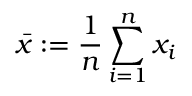Convert formula to latex. <formula><loc_0><loc_0><loc_500><loc_500>\bar { x } \colon = \frac { 1 } { n } \sum _ { i = 1 } ^ { n } x _ { i }</formula> 